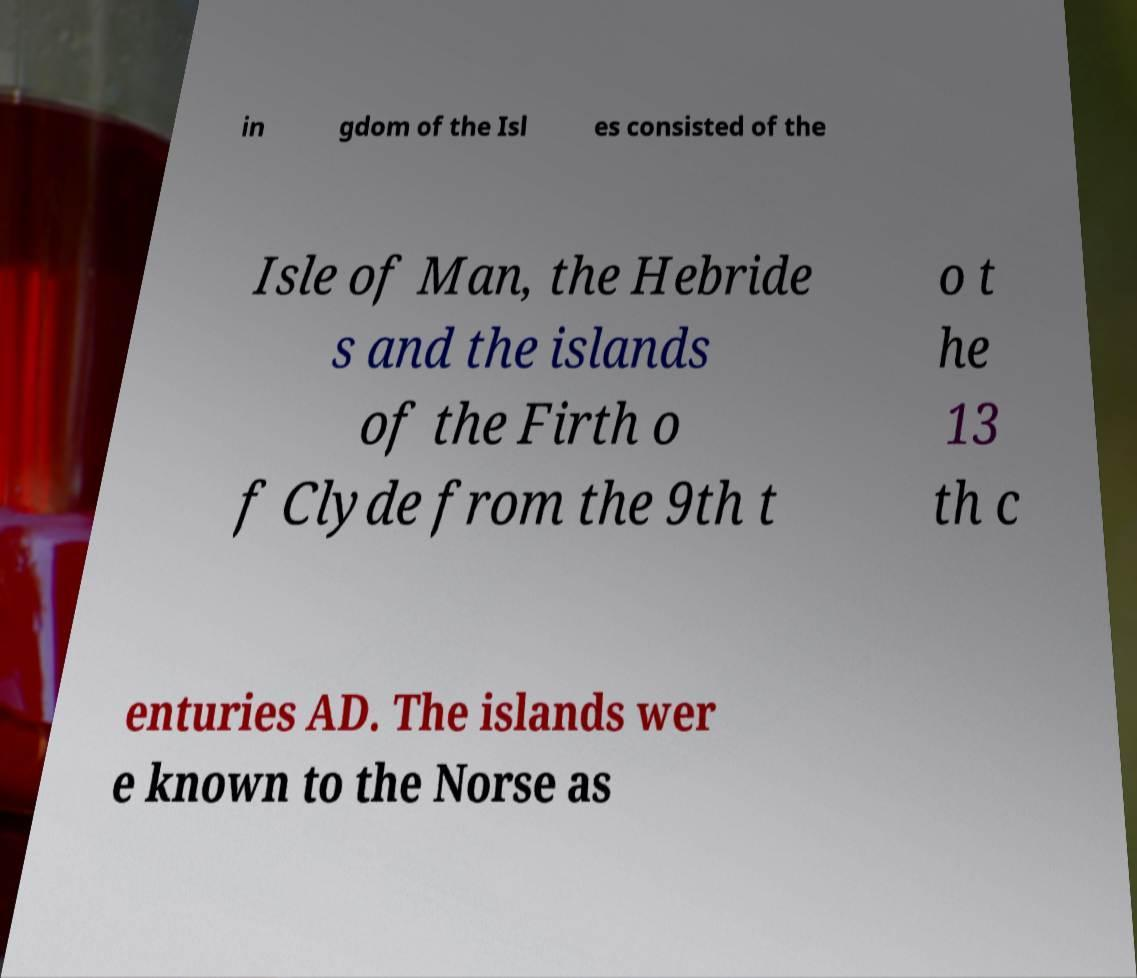Can you accurately transcribe the text from the provided image for me? in gdom of the Isl es consisted of the Isle of Man, the Hebride s and the islands of the Firth o f Clyde from the 9th t o t he 13 th c enturies AD. The islands wer e known to the Norse as 